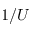<formula> <loc_0><loc_0><loc_500><loc_500>1 / U</formula> 